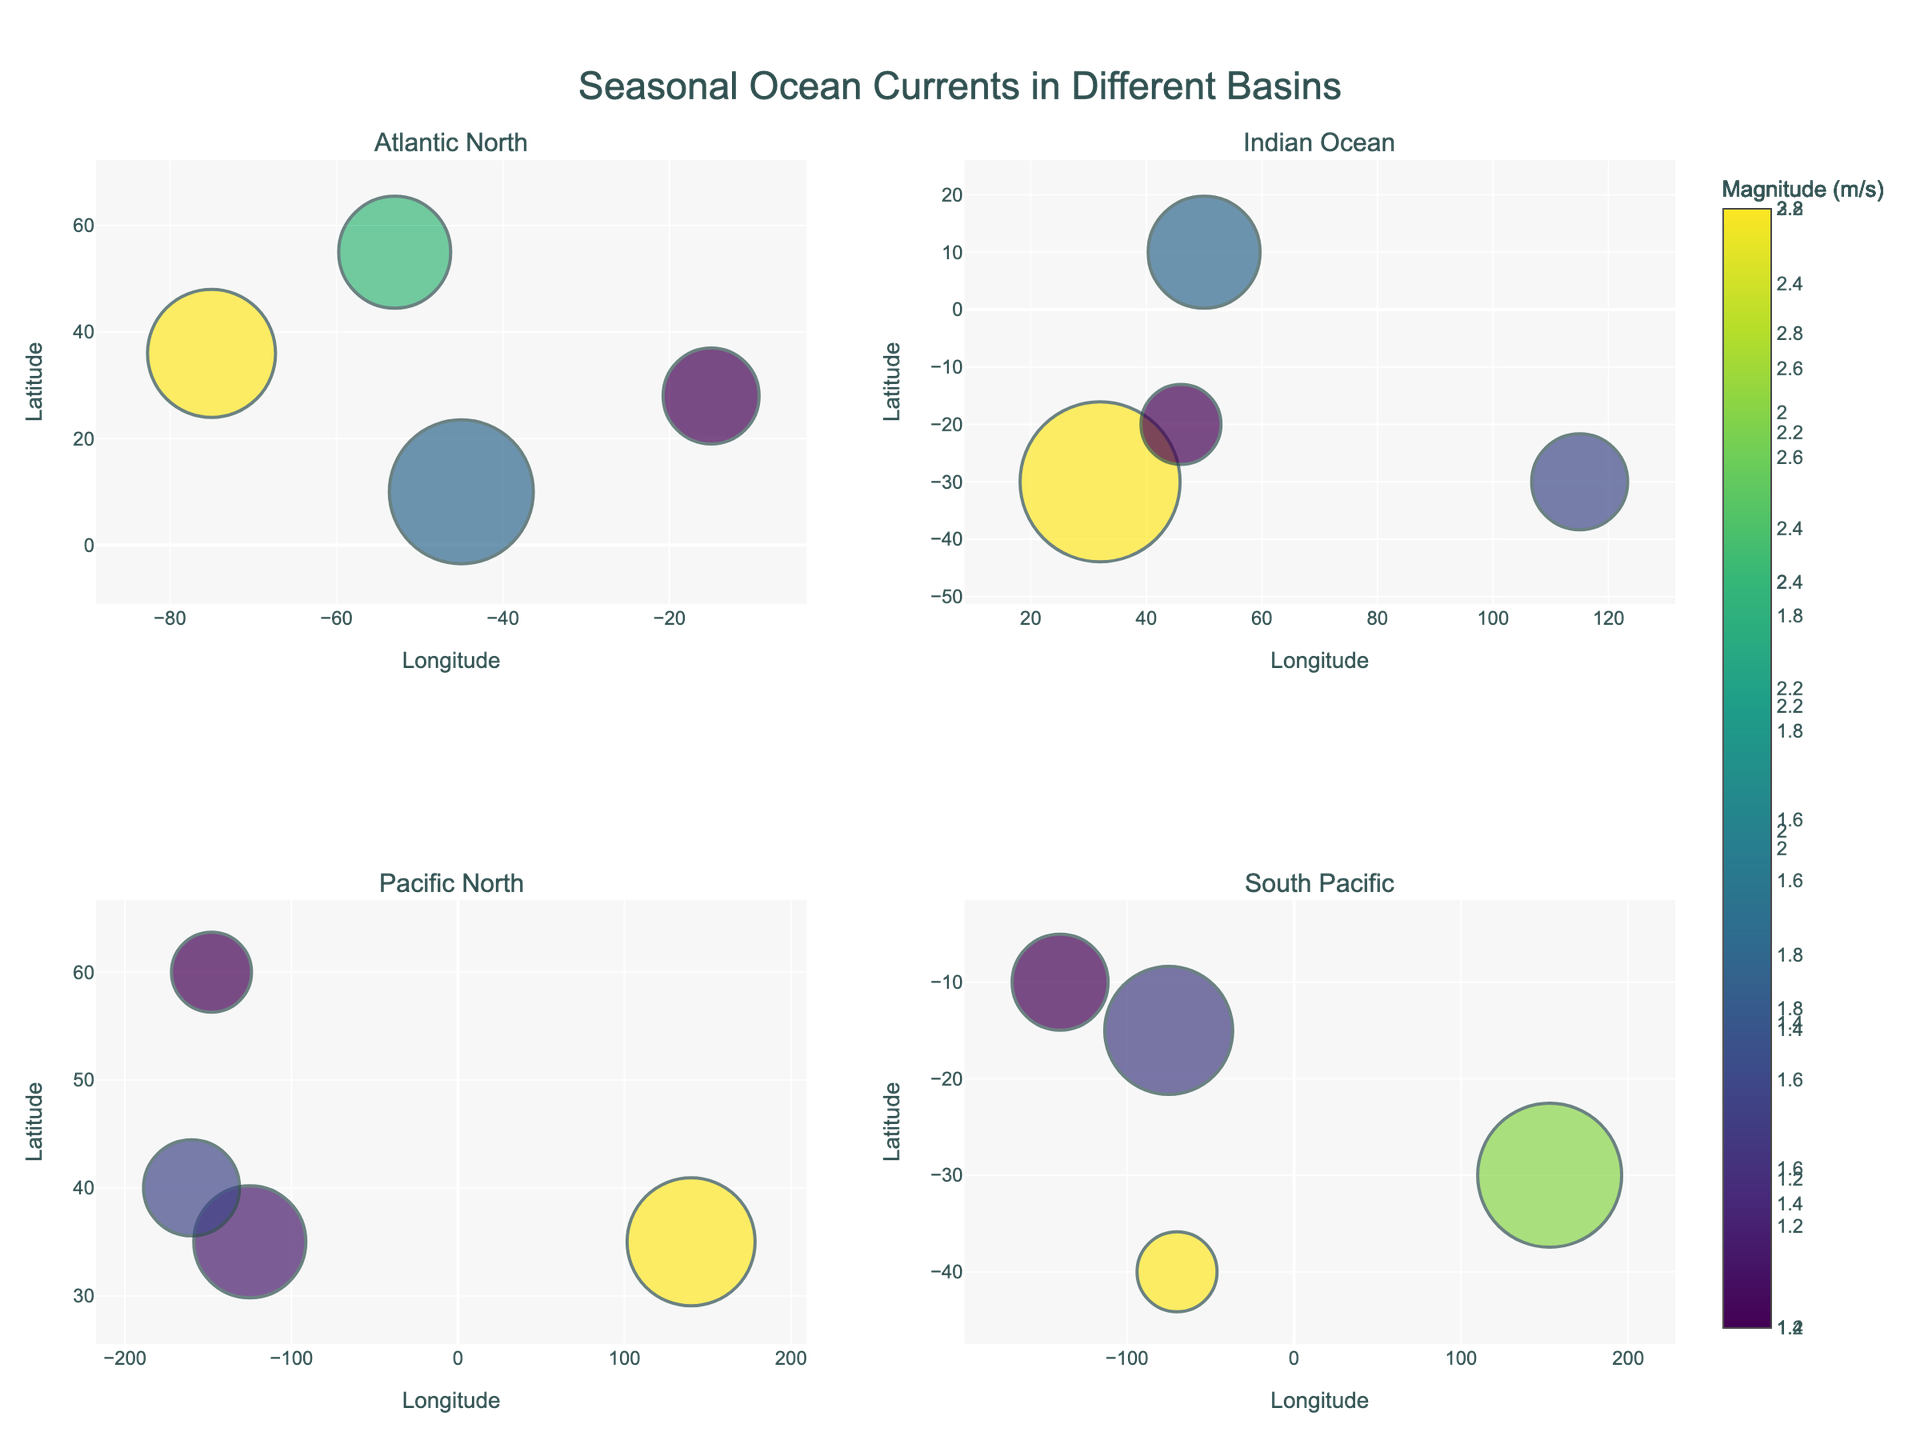- What is the title of the figure? The title of the figure is located at the top and is prominently displayed. It is "Seasonal Ocean Currents in Different Basins."
Answer: Seasonal Ocean Currents in Different Basins - Which ocean basin has the current with the highest magnitude in spring? In the spring subplot, we compare the magnitudes of currents. The Agulhas Current in the Indian Ocean has the highest magnitude of 3.0 m/s.
Answer: Indian Ocean - How many data points are presented in the South Pacific basin subplot? The subplot for the South Pacific contains markers representing different currents for each season. Counting these markers, we find there are four data points.
Answer: 4 - What is the longitude range for the Indian Ocean currents? By examining the x-axes of the Indian Ocean subplot, we see the longitudes range from approximately 32.0 to 115.0.
Answer: 32.0 to 115.0 - Which season has the most frequent occurrence of ocean currents in the Atlantic North basin? By looking at the size of the bubbles and their associated labels in the Atlantic North subplot, the North Equatorial Current in fall occurs 9 times per year, which is the most frequent.
Answer: Fall - Which two ocean basins have a current with a frequency of 8 occurrences/year in summer? In the summer subplot, we check for currents with 8 occurrences/year by analyzing the bubble sizes and colors. The Atlantic North (Canary Current) and South Pacific (Peru Current) both have a frequency of 8.
Answer: Atlantic North, South Pacific - Compare the magnitudes of the Kuroshio Current and the California Current in summer. Which one is stronger? By checking the bubble sizes and colors for these currents in the summer subplot, the Kuroshio Current has a magnitude of 2.8 m/s, and the California Current has 1.5 m/s. The Kuroshio Current is stronger.
Answer: Kuroshio Current - What is the average magnitude of all recorded currents in the winter across all basins? We find the magnitudes of the four currents in winter (2.0, 1.6, 1.4, 2.2). Summing these values gives 7.2, and the average is 7.2/4 = 1.8.
Answer: 1.8 